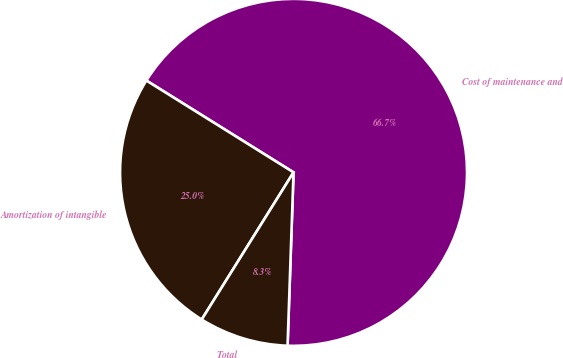<chart> <loc_0><loc_0><loc_500><loc_500><pie_chart><fcel>Cost of maintenance and<fcel>Amortization of intangible<fcel>Total<nl><fcel>66.67%<fcel>25.0%<fcel>8.33%<nl></chart> 